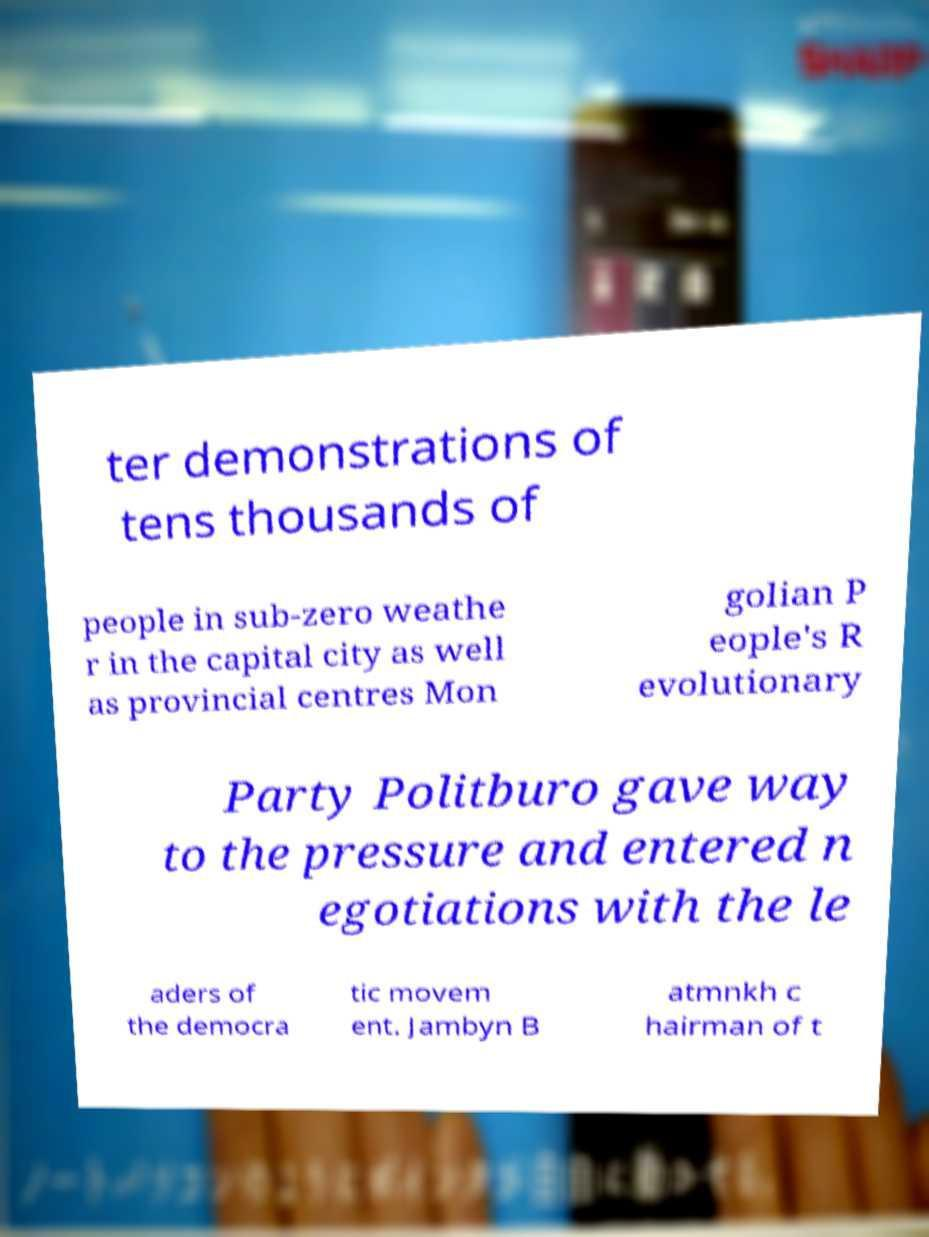Could you assist in decoding the text presented in this image and type it out clearly? ter demonstrations of tens thousands of people in sub-zero weathe r in the capital city as well as provincial centres Mon golian P eople's R evolutionary Party Politburo gave way to the pressure and entered n egotiations with the le aders of the democra tic movem ent. Jambyn B atmnkh c hairman of t 